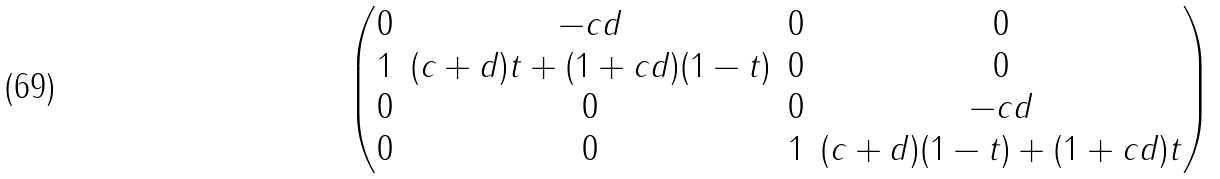<formula> <loc_0><loc_0><loc_500><loc_500>\begin{pmatrix} 0 & - c d & 0 & 0 \\ 1 & ( c + d ) t + ( 1 + c d ) ( 1 - t ) & 0 & 0 \\ 0 & 0 & 0 & - c d \\ 0 & 0 & 1 & ( c + d ) ( 1 - t ) + ( 1 + c d ) t \end{pmatrix}</formula> 